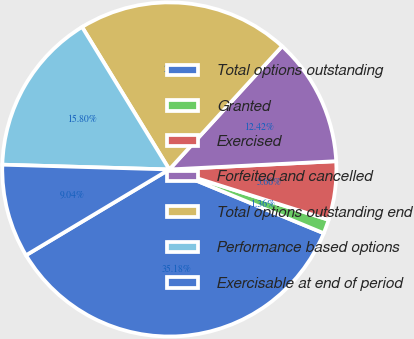Convert chart. <chart><loc_0><loc_0><loc_500><loc_500><pie_chart><fcel>Total options outstanding<fcel>Granted<fcel>Exercised<fcel>Forfeited and cancelled<fcel>Total options outstanding end<fcel>Performance based options<fcel>Exercisable at end of period<nl><fcel>35.18%<fcel>1.36%<fcel>5.66%<fcel>12.42%<fcel>20.54%<fcel>15.8%<fcel>9.04%<nl></chart> 